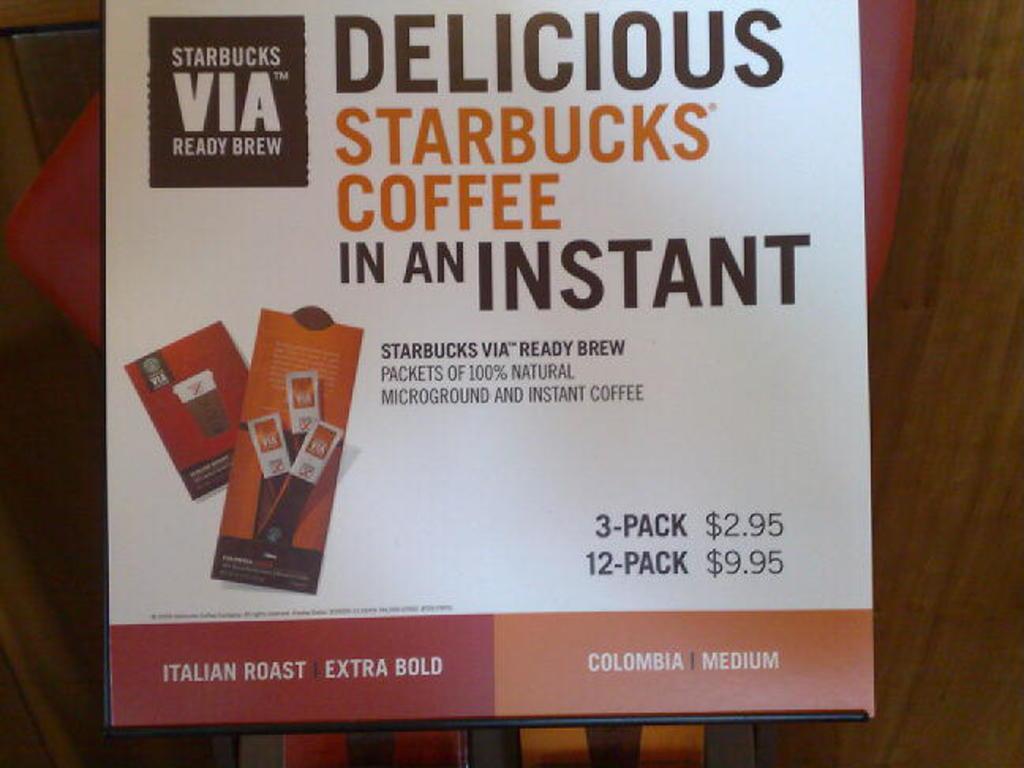What brand is this?
Your answer should be compact. Starbucks. 